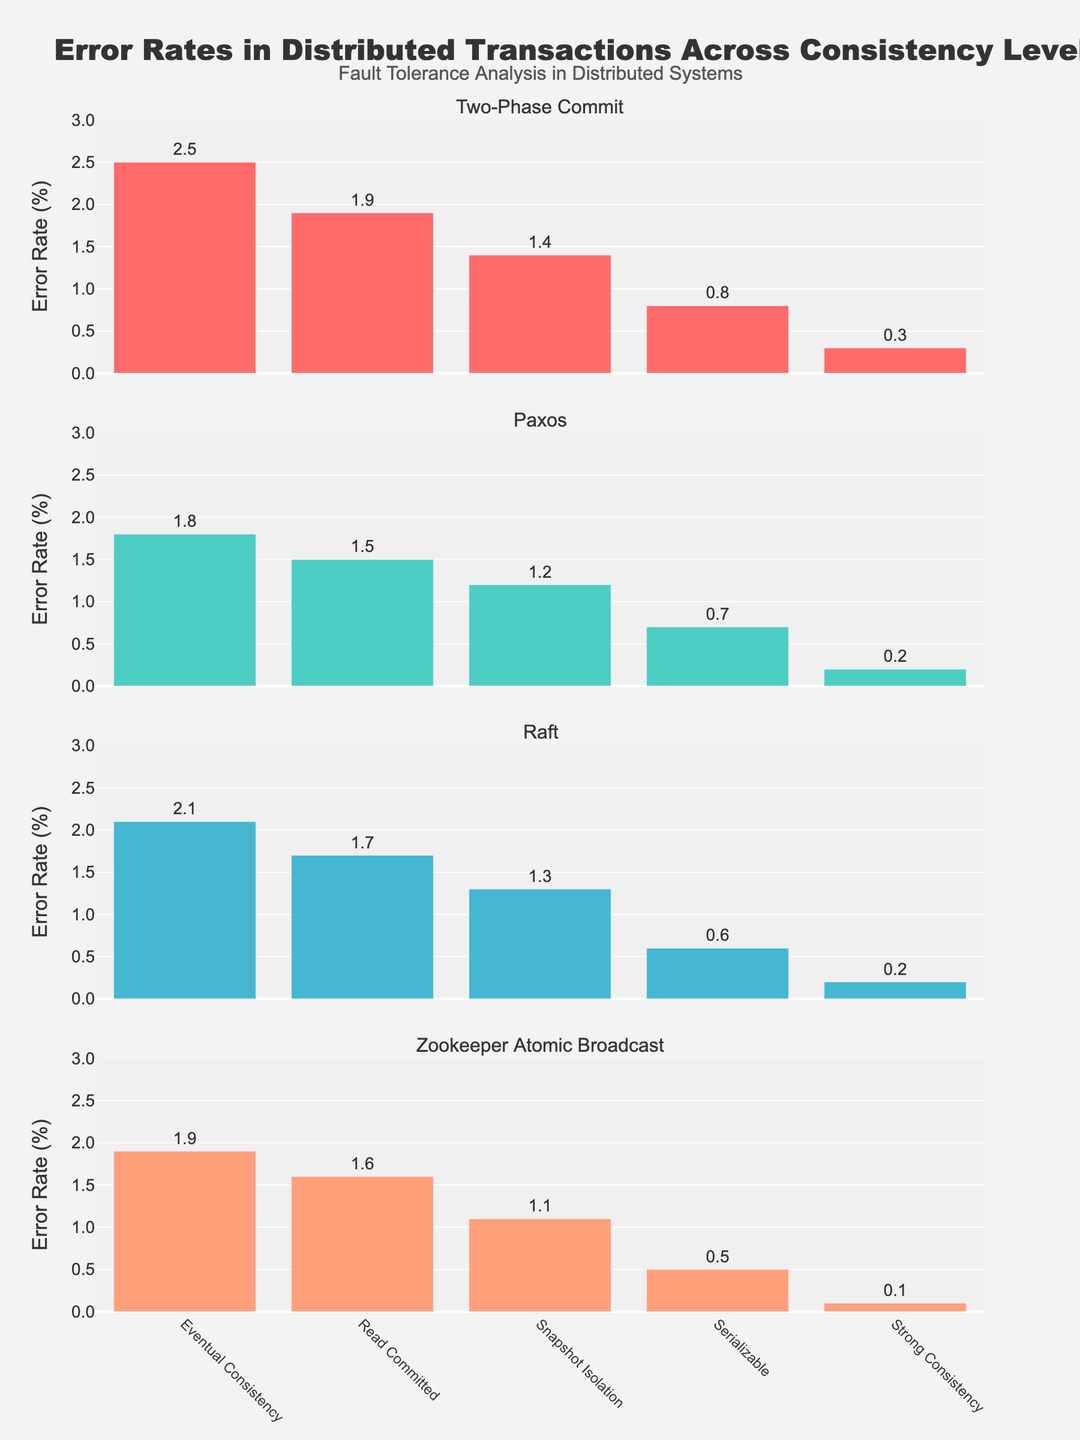How many subplots are there in the figure? The figure has one subplot for each protocol. By counting the number of subplot titles, you can determine that there are 4 subplots in the figure.
Answer: 4 What is the error rate for Raft under Strong Consistency? Look for the vertical bar corresponding to Raft in the Strong Consistency category and check the value label on this bar. It indicates an error rate of 0.2
Answer: 0.2 Which protocol has the lowest error rate for Eventual Consistency? To find the protocol with the lowest error rate for Eventual Consistency, compare the heights of the bars in the Eventual Consistency category. The shortest bar is for Paxos with a value of 1.8.
Answer: Paxos What is the difference in error rates between Read Committed and Serializable for Zookeeper Atomic Broadcast? First, find the error rates for Zookeeper Atomic Broadcast under Read Committed (1.6) and Serializable (0.5). Then, subtract the Serializable error rate from the Read Committed rate: 1.6 - 0.5 = 1.1
Answer: 1.1 Which consistency level shows the greatest difference in error rates between Two-Phase Commit and Paxos? Calculate the differences between Two-Phase Commit and Paxos error rates for each consistency level: Eventual Consistency (2.5 - 1.8 = 0.7), Read Committed (1.9 - 1.5 = 0.4), Snapshot Isolation (1.4 - 1.2 = 0.2), Serializable (0.8 - 0.7 = 0.1), Strong Consistency (0.3 - 0.2 = 0.1). The greatest difference is 0.7 for Eventual Consistency.
Answer: Eventual Consistency What is the average error rate for Paxos across all consistency levels? Add up the error rates for Paxos across all consistency levels: 1.8 + 1.5 + 1.2 + 0.7 + 0.2 = 5.4. Divide the sum by the number of levels, which is 5: 5.4 / 5 = 1.08
Answer: 1.08 How does the error rate trend for Two-Phase Commit change from Eventual Consistency to Strong Consistency? Observe the bars for Two-Phase Commit as consistency levels transition from Eventual Consistency (highest bar) to Strong Consistency (lowest bar). The error rates reduce consistently from 2.5 to 0.3.
Answer: It decreases Which protocol exhibits the smallest variance in error rates across all consistency levels? Compare the range of error rates (highest minus lowest) for each protocol: Two-Phase Commit (2.5 - 0.3 = 2.2), Paxos (1.8 - 0.2 = 1.6), Raft (2.1 - 0.2 = 1.9), Zookeeper Atomic Broadcast (1.9 - 0.1 = 1.8). Paxos has the smallest range of 1.6.
Answer: Paxos 